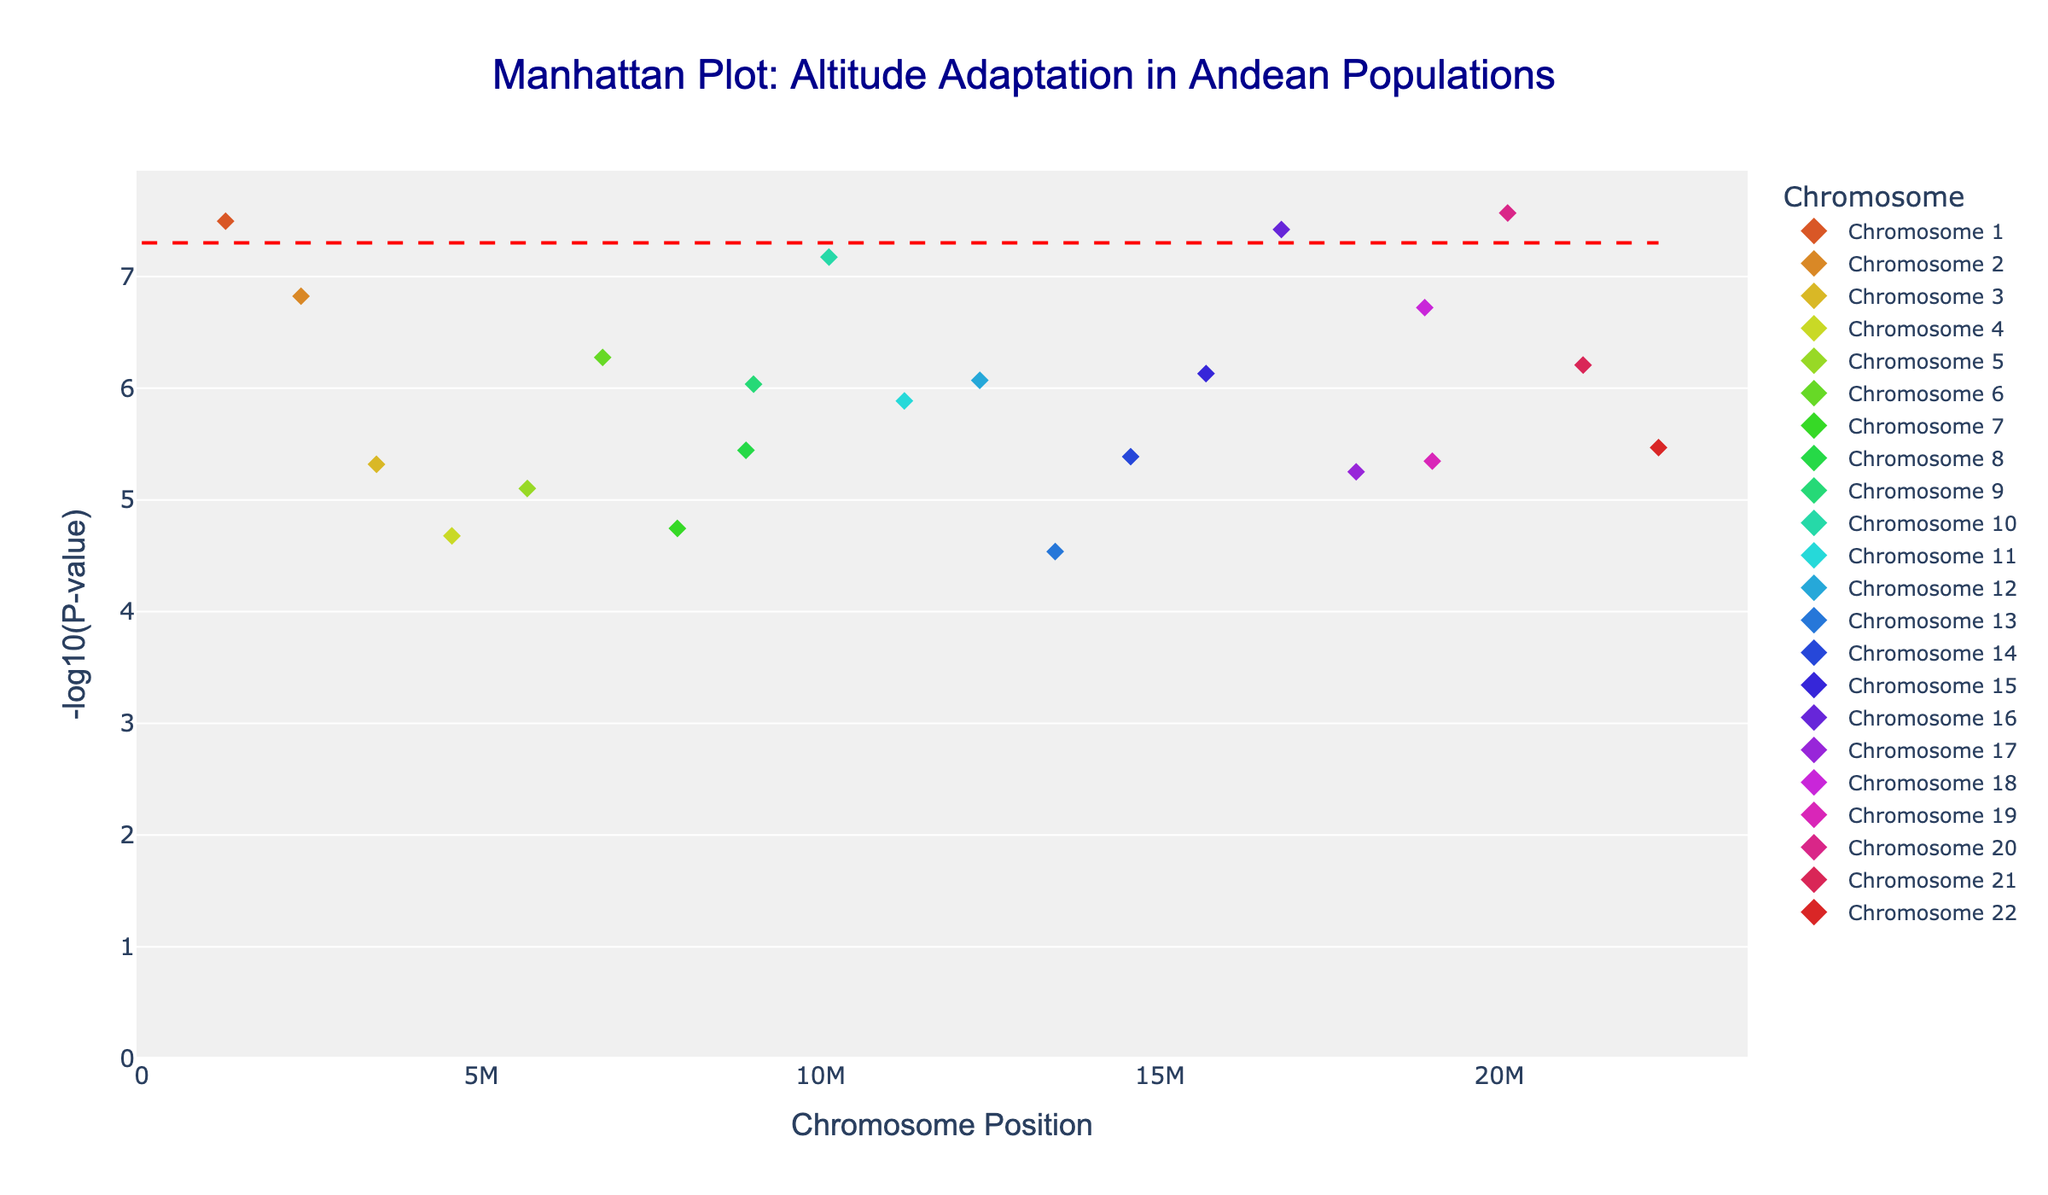What is the title of the plot? The title is shown at the top of the plot in a larger and distinct font to indicate the main subject of the visualization.
Answer: Manhattan Plot: Altitude Adaptation in Andean Populations What do the x and y axes represent? The x-axis represents the chromosome position, and the y-axis represents the -log10(P-value) of the SNPs.
Answer: Chromosome Position and -log10(P-value) How many chromosomes are represented in the plot? The different colored points in the plot represent different chromosomes. Counting the unique colors should match the number of chromosomes.
Answer: 22 Which chromosome has the SNP with the lowest P-value? By identifying the data point with the highest -log10(P-value), you can trace it back to its chromosome based on color coding.
Answer: Chromosome 16 What is the significance threshold shown in the plot, and how is it indicated? The plot has a red dashed horizontal line. This line is the significance threshold. The y-value of this line corresponds to -log10(5e-8).
Answer: -log10(5e-8) How many SNPs fall below the significance threshold? Count the number of points that lie above the red dashed horizontal line (since higher -log10(P-value) means lower P-value).
Answer: 4 Which SNP has the second lowest P-value, and on which chromosome is it located? The second highest -log10(P-value) will correspond to the second lowest P-value. Trace this point back to the SNP and chromosome based on the hover text.
Answer: rs1042713 on Chromosome 10 On which chromosomes do SNP rs7412 appear, and what are its P-values for these chromosomes? Locate the points labeled rs7412 based on hover text and identify the chromosomes and note their P-values.
Answer: Chromosome 4 and 20; P-values are 2.1e-5 and 2.7e-8 respectively Between chromosomes 5 and 12, which has a lower minimum P-value? Compare the highest -log10(P-value) points on both chromosomes. The higher the -log10(P-value), the lower the P-value.
Answer: Chromosome 12 What is the P-value for SNP rs7412 on Chromosome 20 in scientific notation? Locate the SNP rs7412 on Chromosome 20 and note its P-value directly from the hover text.
Answer: 2.7e-8 